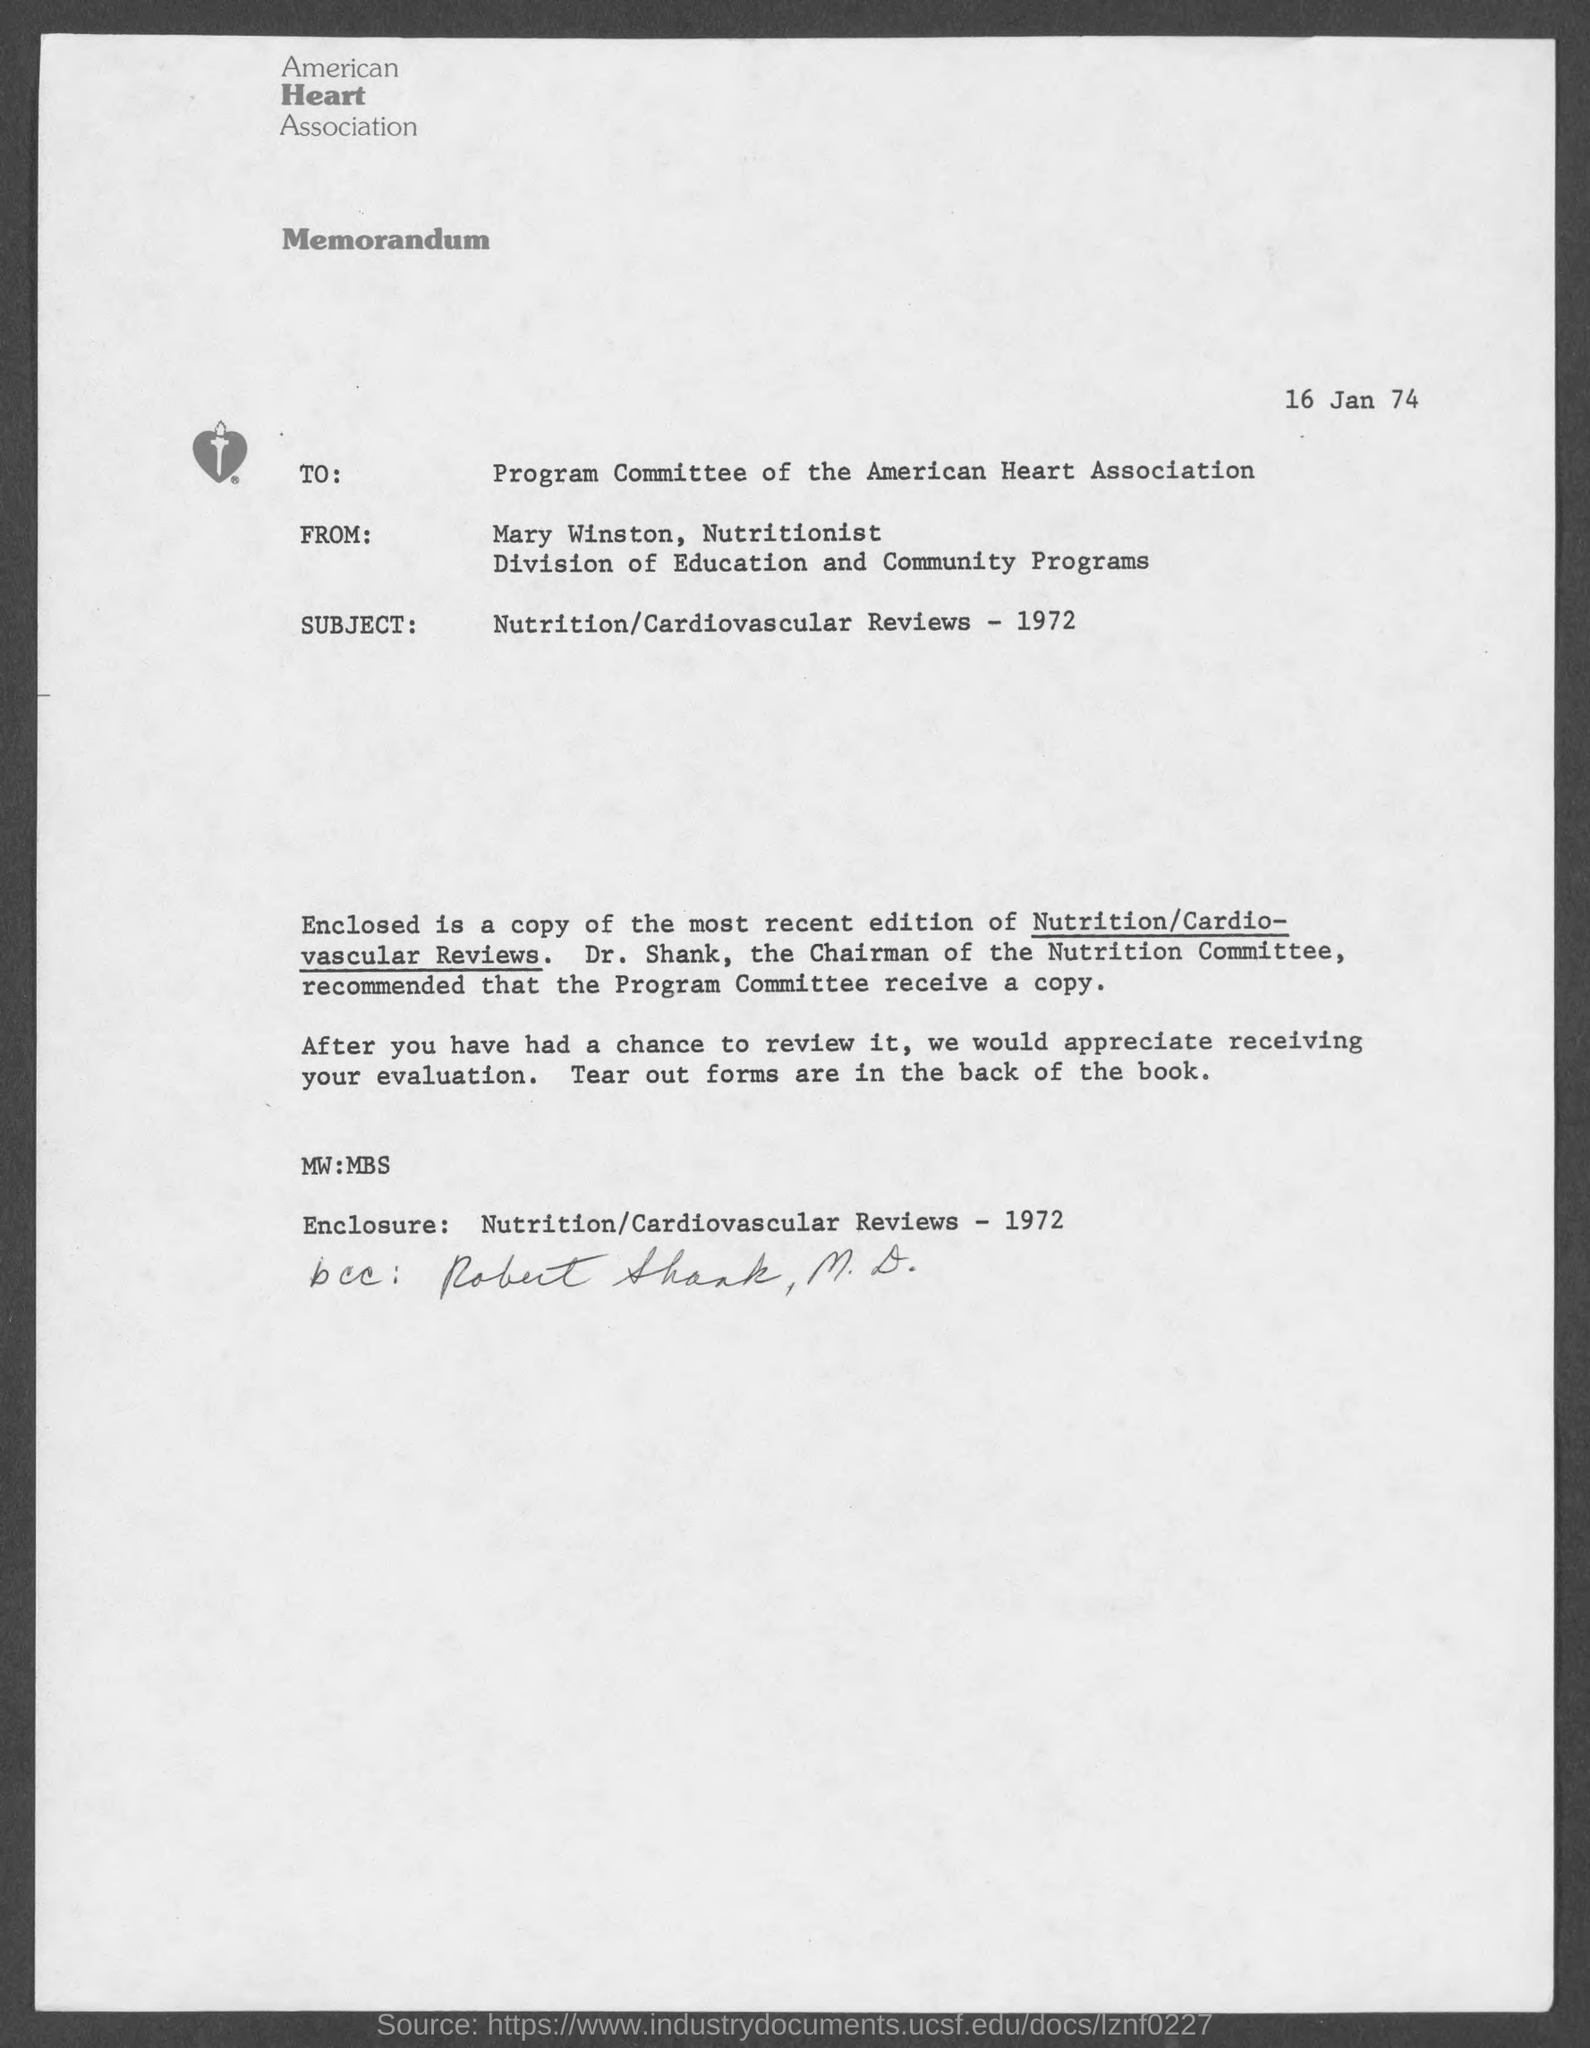What is the name of heart association ?
Provide a succinct answer. American. When is the memorandum dated?
Give a very brief answer. 16 Jan 74. What is the position of mary winston ?
Provide a succinct answer. Nutritionist. Who wrote this memorandum ?
Keep it short and to the point. Mary winston. 